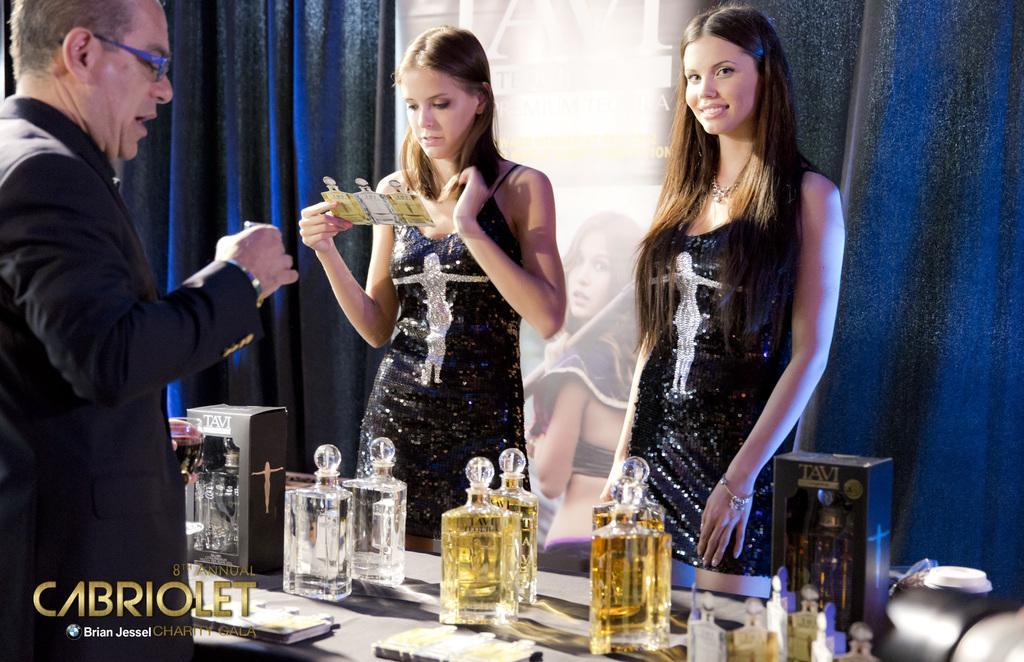How would you summarize this image in a sentence or two? In this picture we can see a man and two women are standing, at the bottom there is table, we can see some bottles and boxes present on the table, in the background there are curtains and a hoarding, a woman in the middle is holding a card, there is some text at the left bottom. 